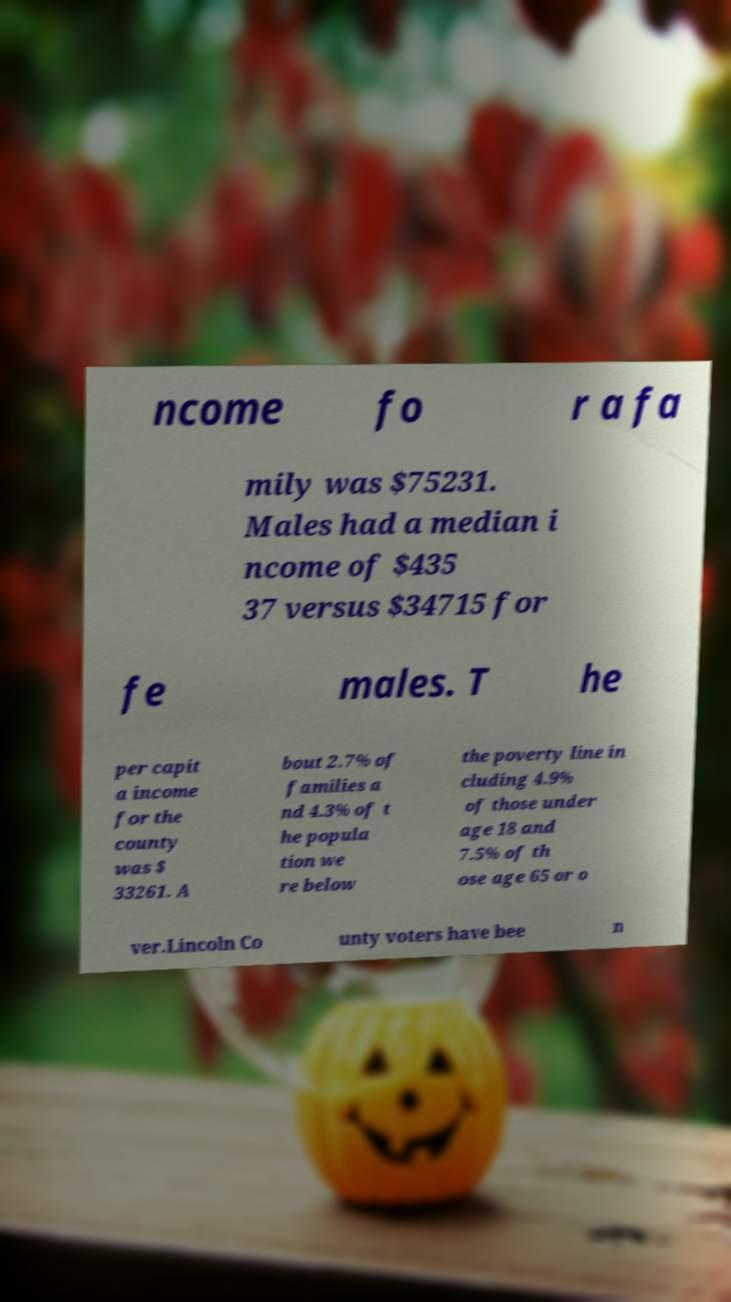Could you assist in decoding the text presented in this image and type it out clearly? ncome fo r a fa mily was $75231. Males had a median i ncome of $435 37 versus $34715 for fe males. T he per capit a income for the county was $ 33261. A bout 2.7% of families a nd 4.3% of t he popula tion we re below the poverty line in cluding 4.9% of those under age 18 and 7.5% of th ose age 65 or o ver.Lincoln Co unty voters have bee n 